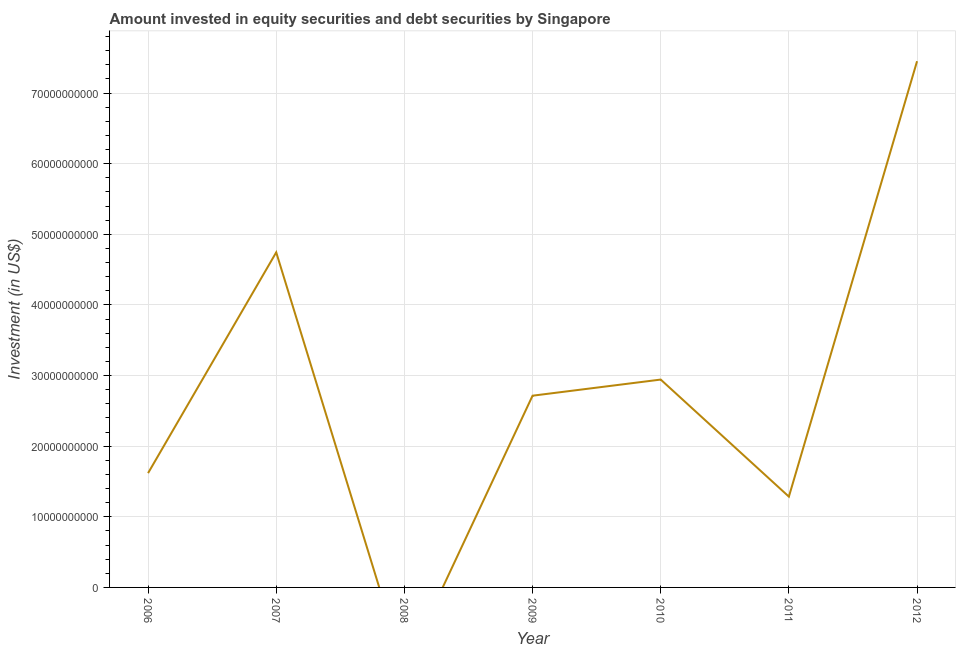What is the portfolio investment in 2012?
Offer a very short reply. 7.45e+1. Across all years, what is the maximum portfolio investment?
Your answer should be very brief. 7.45e+1. In which year was the portfolio investment maximum?
Offer a terse response. 2012. What is the sum of the portfolio investment?
Keep it short and to the point. 2.08e+11. What is the difference between the portfolio investment in 2007 and 2012?
Provide a short and direct response. -2.71e+1. What is the average portfolio investment per year?
Your answer should be compact. 2.97e+1. What is the median portfolio investment?
Offer a terse response. 2.72e+1. In how many years, is the portfolio investment greater than 28000000000 US$?
Give a very brief answer. 3. What is the ratio of the portfolio investment in 2009 to that in 2011?
Keep it short and to the point. 2.11. Is the portfolio investment in 2006 less than that in 2007?
Keep it short and to the point. Yes. Is the difference between the portfolio investment in 2009 and 2010 greater than the difference between any two years?
Provide a short and direct response. No. What is the difference between the highest and the second highest portfolio investment?
Make the answer very short. 2.71e+1. What is the difference between the highest and the lowest portfolio investment?
Make the answer very short. 7.45e+1. Does the portfolio investment monotonically increase over the years?
Provide a succinct answer. No. How many lines are there?
Give a very brief answer. 1. How many years are there in the graph?
Offer a terse response. 7. Does the graph contain any zero values?
Ensure brevity in your answer.  Yes. What is the title of the graph?
Provide a succinct answer. Amount invested in equity securities and debt securities by Singapore. What is the label or title of the X-axis?
Provide a succinct answer. Year. What is the label or title of the Y-axis?
Your answer should be compact. Investment (in US$). What is the Investment (in US$) of 2006?
Ensure brevity in your answer.  1.62e+1. What is the Investment (in US$) of 2007?
Give a very brief answer. 4.74e+1. What is the Investment (in US$) of 2008?
Ensure brevity in your answer.  0. What is the Investment (in US$) in 2009?
Your answer should be compact. 2.72e+1. What is the Investment (in US$) of 2010?
Your answer should be compact. 2.94e+1. What is the Investment (in US$) in 2011?
Keep it short and to the point. 1.29e+1. What is the Investment (in US$) in 2012?
Provide a short and direct response. 7.45e+1. What is the difference between the Investment (in US$) in 2006 and 2007?
Give a very brief answer. -3.13e+1. What is the difference between the Investment (in US$) in 2006 and 2009?
Your answer should be compact. -1.10e+1. What is the difference between the Investment (in US$) in 2006 and 2010?
Provide a succinct answer. -1.32e+1. What is the difference between the Investment (in US$) in 2006 and 2011?
Make the answer very short. 3.33e+09. What is the difference between the Investment (in US$) in 2006 and 2012?
Give a very brief answer. -5.83e+1. What is the difference between the Investment (in US$) in 2007 and 2009?
Provide a succinct answer. 2.03e+1. What is the difference between the Investment (in US$) in 2007 and 2010?
Your answer should be compact. 1.80e+1. What is the difference between the Investment (in US$) in 2007 and 2011?
Provide a succinct answer. 3.46e+1. What is the difference between the Investment (in US$) in 2007 and 2012?
Offer a very short reply. -2.71e+1. What is the difference between the Investment (in US$) in 2009 and 2010?
Offer a very short reply. -2.28e+09. What is the difference between the Investment (in US$) in 2009 and 2011?
Ensure brevity in your answer.  1.43e+1. What is the difference between the Investment (in US$) in 2009 and 2012?
Keep it short and to the point. -4.74e+1. What is the difference between the Investment (in US$) in 2010 and 2011?
Offer a very short reply. 1.66e+1. What is the difference between the Investment (in US$) in 2010 and 2012?
Make the answer very short. -4.51e+1. What is the difference between the Investment (in US$) in 2011 and 2012?
Provide a short and direct response. -6.17e+1. What is the ratio of the Investment (in US$) in 2006 to that in 2007?
Keep it short and to the point. 0.34. What is the ratio of the Investment (in US$) in 2006 to that in 2009?
Offer a very short reply. 0.6. What is the ratio of the Investment (in US$) in 2006 to that in 2010?
Your answer should be very brief. 0.55. What is the ratio of the Investment (in US$) in 2006 to that in 2011?
Provide a short and direct response. 1.26. What is the ratio of the Investment (in US$) in 2006 to that in 2012?
Keep it short and to the point. 0.22. What is the ratio of the Investment (in US$) in 2007 to that in 2009?
Your answer should be very brief. 1.75. What is the ratio of the Investment (in US$) in 2007 to that in 2010?
Ensure brevity in your answer.  1.61. What is the ratio of the Investment (in US$) in 2007 to that in 2011?
Offer a very short reply. 3.69. What is the ratio of the Investment (in US$) in 2007 to that in 2012?
Make the answer very short. 0.64. What is the ratio of the Investment (in US$) in 2009 to that in 2010?
Offer a terse response. 0.92. What is the ratio of the Investment (in US$) in 2009 to that in 2011?
Offer a terse response. 2.11. What is the ratio of the Investment (in US$) in 2009 to that in 2012?
Make the answer very short. 0.36. What is the ratio of the Investment (in US$) in 2010 to that in 2011?
Keep it short and to the point. 2.29. What is the ratio of the Investment (in US$) in 2010 to that in 2012?
Give a very brief answer. 0.4. What is the ratio of the Investment (in US$) in 2011 to that in 2012?
Offer a terse response. 0.17. 